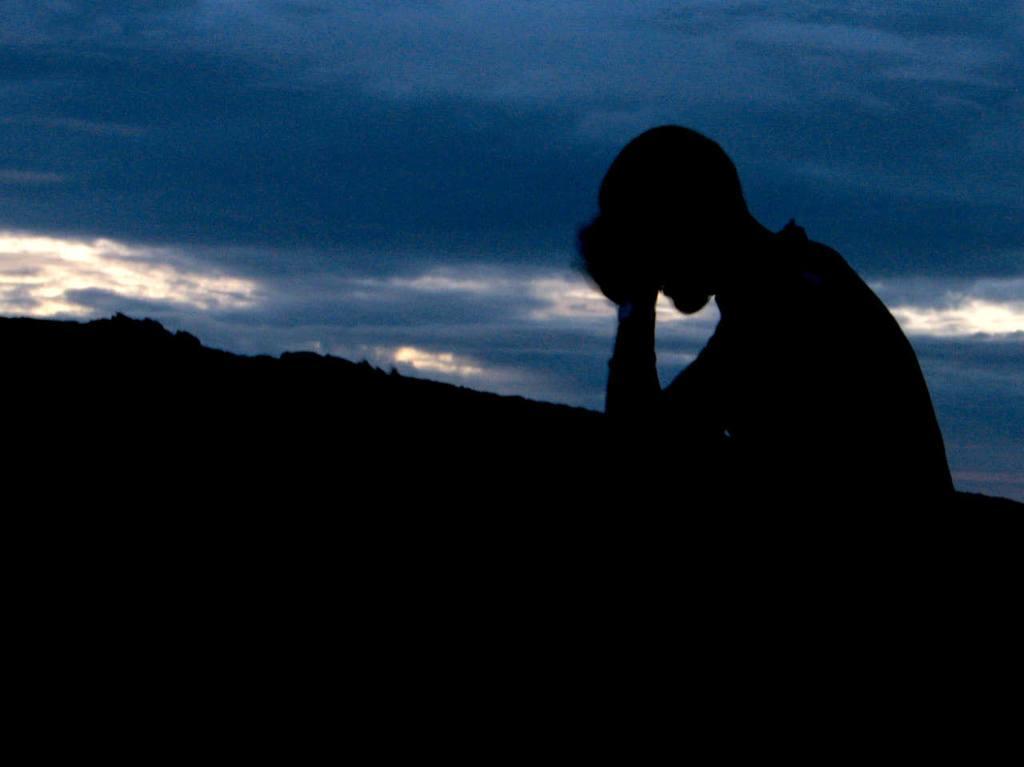Please provide a concise description of this image. On the right side of the image a person is there. In the middle of the image hills are present. At the top of the image clouds are present in the sky. 